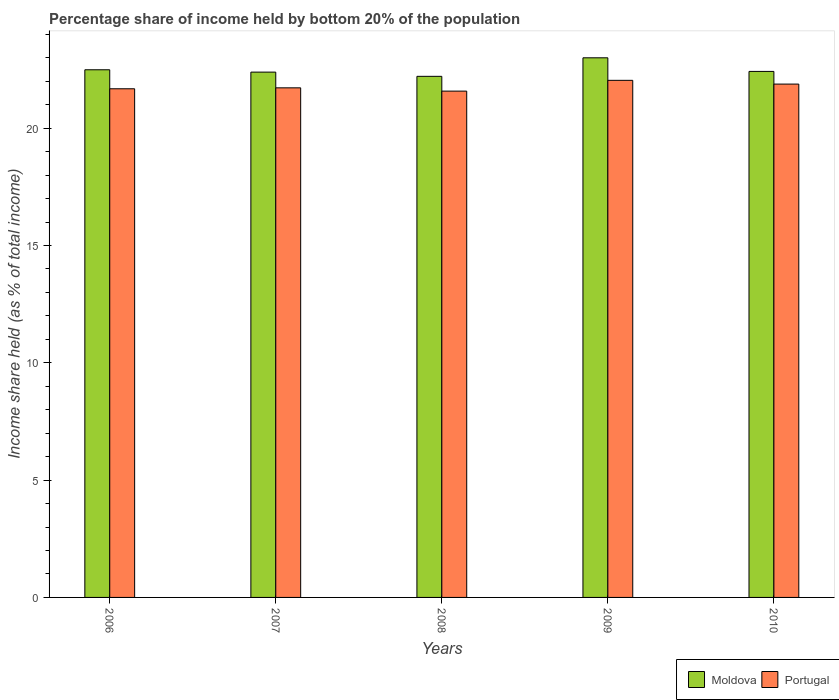How many different coloured bars are there?
Provide a succinct answer. 2. How many groups of bars are there?
Ensure brevity in your answer.  5. Are the number of bars per tick equal to the number of legend labels?
Offer a very short reply. Yes. What is the share of income held by bottom 20% of the population in Portugal in 2006?
Make the answer very short. 21.68. Across all years, what is the maximum share of income held by bottom 20% of the population in Portugal?
Provide a succinct answer. 22.04. Across all years, what is the minimum share of income held by bottom 20% of the population in Moldova?
Provide a succinct answer. 22.21. In which year was the share of income held by bottom 20% of the population in Portugal minimum?
Ensure brevity in your answer.  2008. What is the total share of income held by bottom 20% of the population in Portugal in the graph?
Provide a short and direct response. 108.9. What is the difference between the share of income held by bottom 20% of the population in Moldova in 2008 and that in 2010?
Offer a very short reply. -0.21. What is the difference between the share of income held by bottom 20% of the population in Moldova in 2007 and the share of income held by bottom 20% of the population in Portugal in 2010?
Provide a short and direct response. 0.51. What is the average share of income held by bottom 20% of the population in Moldova per year?
Offer a terse response. 22.5. In the year 2009, what is the difference between the share of income held by bottom 20% of the population in Moldova and share of income held by bottom 20% of the population in Portugal?
Your response must be concise. 0.96. What is the ratio of the share of income held by bottom 20% of the population in Portugal in 2006 to that in 2010?
Your answer should be compact. 0.99. Is the difference between the share of income held by bottom 20% of the population in Moldova in 2007 and 2008 greater than the difference between the share of income held by bottom 20% of the population in Portugal in 2007 and 2008?
Offer a very short reply. Yes. What is the difference between the highest and the second highest share of income held by bottom 20% of the population in Portugal?
Ensure brevity in your answer.  0.16. What is the difference between the highest and the lowest share of income held by bottom 20% of the population in Moldova?
Your response must be concise. 0.79. In how many years, is the share of income held by bottom 20% of the population in Portugal greater than the average share of income held by bottom 20% of the population in Portugal taken over all years?
Give a very brief answer. 2. Is the sum of the share of income held by bottom 20% of the population in Portugal in 2008 and 2009 greater than the maximum share of income held by bottom 20% of the population in Moldova across all years?
Offer a very short reply. Yes. What does the 2nd bar from the right in 2006 represents?
Offer a very short reply. Moldova. Are all the bars in the graph horizontal?
Ensure brevity in your answer.  No. What is the difference between two consecutive major ticks on the Y-axis?
Ensure brevity in your answer.  5. How many legend labels are there?
Give a very brief answer. 2. What is the title of the graph?
Ensure brevity in your answer.  Percentage share of income held by bottom 20% of the population. Does "Oman" appear as one of the legend labels in the graph?
Provide a short and direct response. No. What is the label or title of the Y-axis?
Keep it short and to the point. Income share held (as % of total income). What is the Income share held (as % of total income) of Moldova in 2006?
Keep it short and to the point. 22.49. What is the Income share held (as % of total income) of Portugal in 2006?
Provide a succinct answer. 21.68. What is the Income share held (as % of total income) in Moldova in 2007?
Make the answer very short. 22.39. What is the Income share held (as % of total income) of Portugal in 2007?
Provide a succinct answer. 21.72. What is the Income share held (as % of total income) in Moldova in 2008?
Your answer should be compact. 22.21. What is the Income share held (as % of total income) in Portugal in 2008?
Provide a succinct answer. 21.58. What is the Income share held (as % of total income) of Moldova in 2009?
Offer a very short reply. 23. What is the Income share held (as % of total income) of Portugal in 2009?
Keep it short and to the point. 22.04. What is the Income share held (as % of total income) of Moldova in 2010?
Offer a very short reply. 22.42. What is the Income share held (as % of total income) of Portugal in 2010?
Keep it short and to the point. 21.88. Across all years, what is the maximum Income share held (as % of total income) of Portugal?
Your answer should be compact. 22.04. Across all years, what is the minimum Income share held (as % of total income) in Moldova?
Your answer should be compact. 22.21. Across all years, what is the minimum Income share held (as % of total income) of Portugal?
Keep it short and to the point. 21.58. What is the total Income share held (as % of total income) of Moldova in the graph?
Make the answer very short. 112.51. What is the total Income share held (as % of total income) in Portugal in the graph?
Keep it short and to the point. 108.9. What is the difference between the Income share held (as % of total income) in Portugal in 2006 and that in 2007?
Provide a short and direct response. -0.04. What is the difference between the Income share held (as % of total income) of Moldova in 2006 and that in 2008?
Provide a short and direct response. 0.28. What is the difference between the Income share held (as % of total income) in Moldova in 2006 and that in 2009?
Your answer should be very brief. -0.51. What is the difference between the Income share held (as % of total income) in Portugal in 2006 and that in 2009?
Your response must be concise. -0.36. What is the difference between the Income share held (as % of total income) in Moldova in 2006 and that in 2010?
Provide a succinct answer. 0.07. What is the difference between the Income share held (as % of total income) in Portugal in 2006 and that in 2010?
Keep it short and to the point. -0.2. What is the difference between the Income share held (as % of total income) in Moldova in 2007 and that in 2008?
Make the answer very short. 0.18. What is the difference between the Income share held (as % of total income) in Portugal in 2007 and that in 2008?
Your answer should be compact. 0.14. What is the difference between the Income share held (as % of total income) in Moldova in 2007 and that in 2009?
Offer a very short reply. -0.61. What is the difference between the Income share held (as % of total income) in Portugal in 2007 and that in 2009?
Give a very brief answer. -0.32. What is the difference between the Income share held (as % of total income) of Moldova in 2007 and that in 2010?
Offer a terse response. -0.03. What is the difference between the Income share held (as % of total income) in Portugal in 2007 and that in 2010?
Offer a terse response. -0.16. What is the difference between the Income share held (as % of total income) of Moldova in 2008 and that in 2009?
Make the answer very short. -0.79. What is the difference between the Income share held (as % of total income) in Portugal in 2008 and that in 2009?
Offer a terse response. -0.46. What is the difference between the Income share held (as % of total income) of Moldova in 2008 and that in 2010?
Provide a succinct answer. -0.21. What is the difference between the Income share held (as % of total income) in Moldova in 2009 and that in 2010?
Keep it short and to the point. 0.58. What is the difference between the Income share held (as % of total income) in Portugal in 2009 and that in 2010?
Offer a terse response. 0.16. What is the difference between the Income share held (as % of total income) of Moldova in 2006 and the Income share held (as % of total income) of Portugal in 2007?
Make the answer very short. 0.77. What is the difference between the Income share held (as % of total income) in Moldova in 2006 and the Income share held (as % of total income) in Portugal in 2008?
Provide a succinct answer. 0.91. What is the difference between the Income share held (as % of total income) in Moldova in 2006 and the Income share held (as % of total income) in Portugal in 2009?
Offer a very short reply. 0.45. What is the difference between the Income share held (as % of total income) in Moldova in 2006 and the Income share held (as % of total income) in Portugal in 2010?
Offer a very short reply. 0.61. What is the difference between the Income share held (as % of total income) in Moldova in 2007 and the Income share held (as % of total income) in Portugal in 2008?
Your answer should be compact. 0.81. What is the difference between the Income share held (as % of total income) of Moldova in 2007 and the Income share held (as % of total income) of Portugal in 2009?
Provide a succinct answer. 0.35. What is the difference between the Income share held (as % of total income) of Moldova in 2007 and the Income share held (as % of total income) of Portugal in 2010?
Offer a very short reply. 0.51. What is the difference between the Income share held (as % of total income) of Moldova in 2008 and the Income share held (as % of total income) of Portugal in 2009?
Provide a short and direct response. 0.17. What is the difference between the Income share held (as % of total income) of Moldova in 2008 and the Income share held (as % of total income) of Portugal in 2010?
Keep it short and to the point. 0.33. What is the difference between the Income share held (as % of total income) in Moldova in 2009 and the Income share held (as % of total income) in Portugal in 2010?
Make the answer very short. 1.12. What is the average Income share held (as % of total income) in Moldova per year?
Provide a succinct answer. 22.5. What is the average Income share held (as % of total income) of Portugal per year?
Your answer should be very brief. 21.78. In the year 2006, what is the difference between the Income share held (as % of total income) in Moldova and Income share held (as % of total income) in Portugal?
Offer a very short reply. 0.81. In the year 2007, what is the difference between the Income share held (as % of total income) of Moldova and Income share held (as % of total income) of Portugal?
Provide a short and direct response. 0.67. In the year 2008, what is the difference between the Income share held (as % of total income) in Moldova and Income share held (as % of total income) in Portugal?
Offer a terse response. 0.63. In the year 2009, what is the difference between the Income share held (as % of total income) of Moldova and Income share held (as % of total income) of Portugal?
Ensure brevity in your answer.  0.96. In the year 2010, what is the difference between the Income share held (as % of total income) in Moldova and Income share held (as % of total income) in Portugal?
Offer a very short reply. 0.54. What is the ratio of the Income share held (as % of total income) of Moldova in 2006 to that in 2008?
Offer a terse response. 1.01. What is the ratio of the Income share held (as % of total income) in Moldova in 2006 to that in 2009?
Ensure brevity in your answer.  0.98. What is the ratio of the Income share held (as % of total income) in Portugal in 2006 to that in 2009?
Provide a short and direct response. 0.98. What is the ratio of the Income share held (as % of total income) of Portugal in 2006 to that in 2010?
Make the answer very short. 0.99. What is the ratio of the Income share held (as % of total income) of Moldova in 2007 to that in 2008?
Make the answer very short. 1.01. What is the ratio of the Income share held (as % of total income) of Portugal in 2007 to that in 2008?
Ensure brevity in your answer.  1.01. What is the ratio of the Income share held (as % of total income) in Moldova in 2007 to that in 2009?
Provide a short and direct response. 0.97. What is the ratio of the Income share held (as % of total income) of Portugal in 2007 to that in 2009?
Give a very brief answer. 0.99. What is the ratio of the Income share held (as % of total income) of Moldova in 2008 to that in 2009?
Give a very brief answer. 0.97. What is the ratio of the Income share held (as % of total income) in Portugal in 2008 to that in 2009?
Offer a terse response. 0.98. What is the ratio of the Income share held (as % of total income) in Moldova in 2008 to that in 2010?
Keep it short and to the point. 0.99. What is the ratio of the Income share held (as % of total income) in Portugal in 2008 to that in 2010?
Ensure brevity in your answer.  0.99. What is the ratio of the Income share held (as % of total income) of Moldova in 2009 to that in 2010?
Provide a succinct answer. 1.03. What is the ratio of the Income share held (as % of total income) of Portugal in 2009 to that in 2010?
Offer a terse response. 1.01. What is the difference between the highest and the second highest Income share held (as % of total income) in Moldova?
Your answer should be compact. 0.51. What is the difference between the highest and the second highest Income share held (as % of total income) in Portugal?
Make the answer very short. 0.16. What is the difference between the highest and the lowest Income share held (as % of total income) of Moldova?
Give a very brief answer. 0.79. What is the difference between the highest and the lowest Income share held (as % of total income) of Portugal?
Keep it short and to the point. 0.46. 